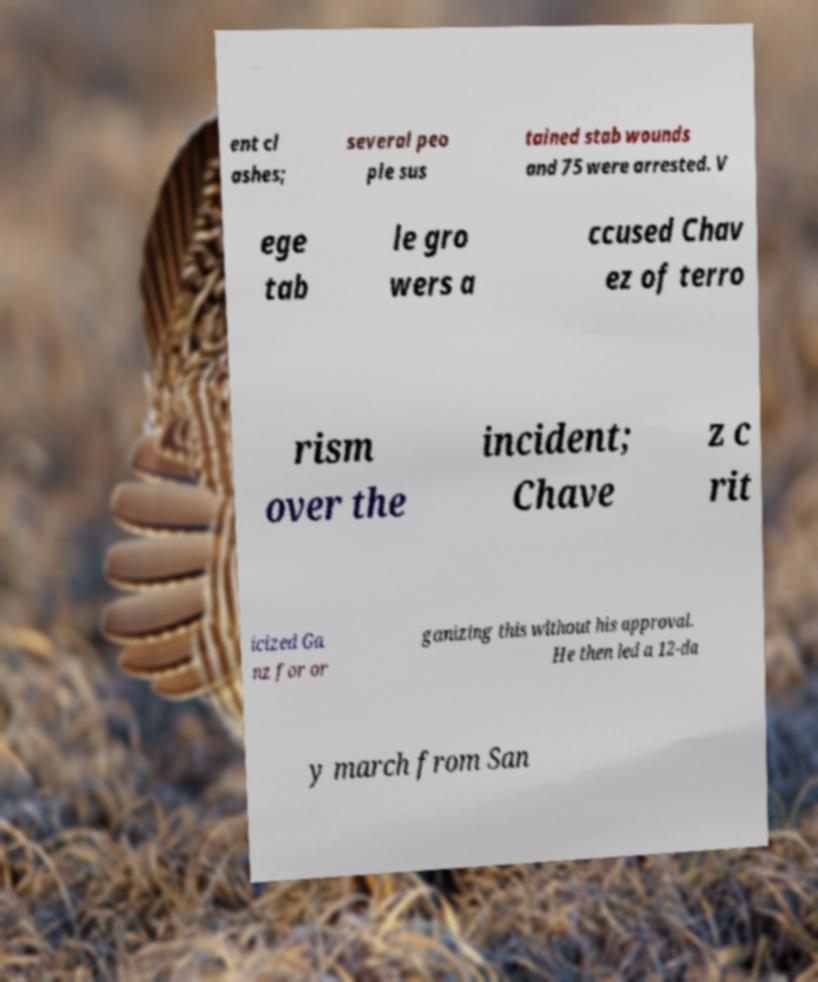I need the written content from this picture converted into text. Can you do that? ent cl ashes; several peo ple sus tained stab wounds and 75 were arrested. V ege tab le gro wers a ccused Chav ez of terro rism over the incident; Chave z c rit icized Ga nz for or ganizing this without his approval. He then led a 12-da y march from San 